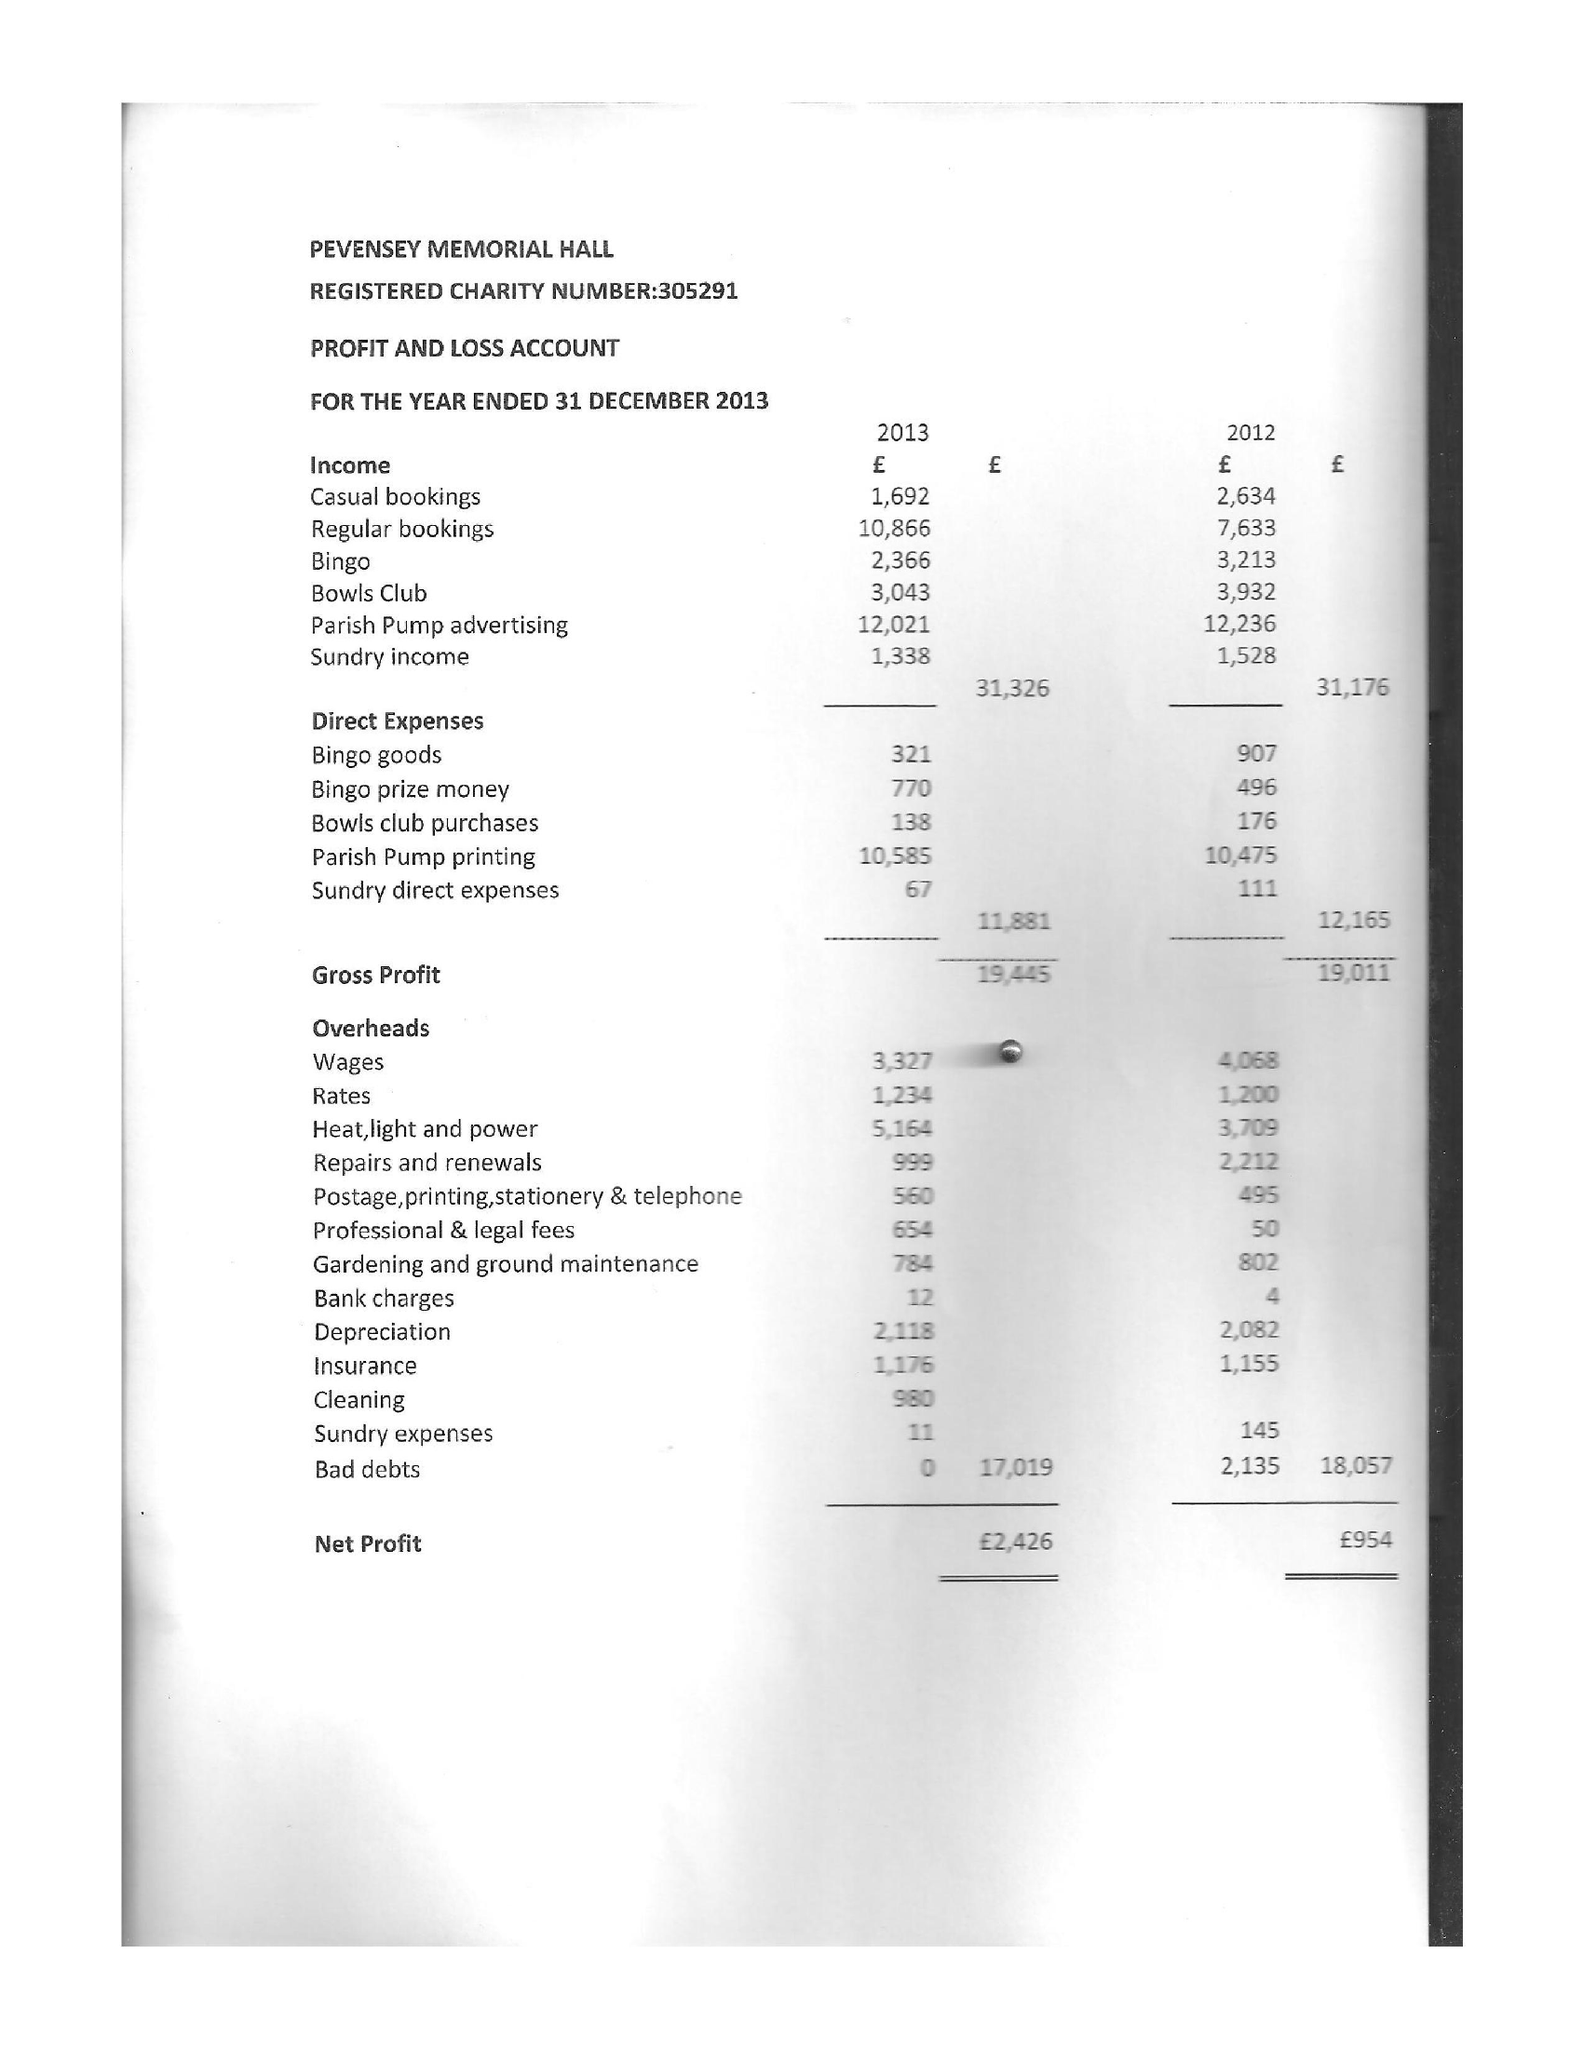What is the value for the spending_annually_in_british_pounds?
Answer the question using a single word or phrase. 36464.00 